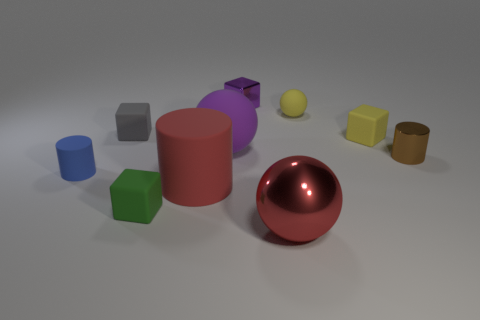How many things are either tiny green matte cylinders or small matte things that are to the left of the small purple shiny cube? Upon reviewing the image, it appears there are two objects that match the description of being tiny green matte cylinders. As for small matte objects to the left of the small purple shiny cube, there is one such object, a yellow matte cube. Therefore, the total count of items meeting your criteria is three. 